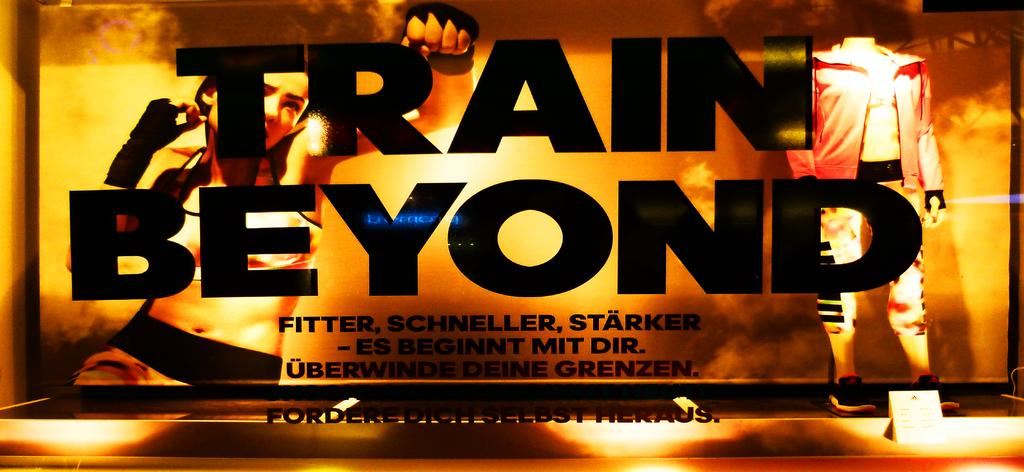Provide a one-sentence caption for the provided image. The sign has large letters encouraging  people to "train beyond". 